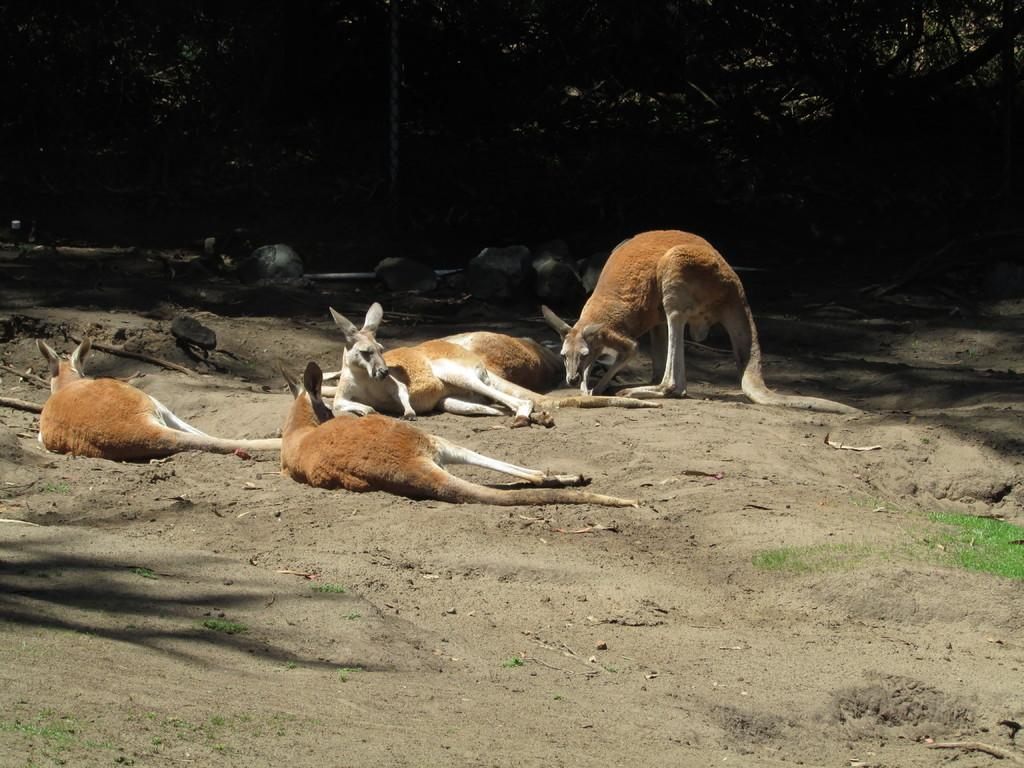What type of surface is visible in the image? There is ground visible in the image. What covers the ground in the image? There is grass on the ground. What animals can be seen in the image? There are kangaroos in the image. What colors are the kangaroos? The kangaroos are white and brown in color. What can be seen in the background of the image? There are trees and rocks in the background of the image. What type of breakfast is being served in the image? There is no breakfast visible in the image; it features kangaroos in a grassy area with trees and rocks in the background. What degree of difficulty is required to set up the tent in the image? There is no tent present in the image. 